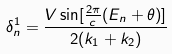Convert formula to latex. <formula><loc_0><loc_0><loc_500><loc_500>\delta ^ { 1 } _ { n } = \frac { V \sin [ \frac { 2 \pi } { c } ( E _ { n } + \theta ) ] } { 2 ( k _ { 1 } + k _ { 2 } ) }</formula> 